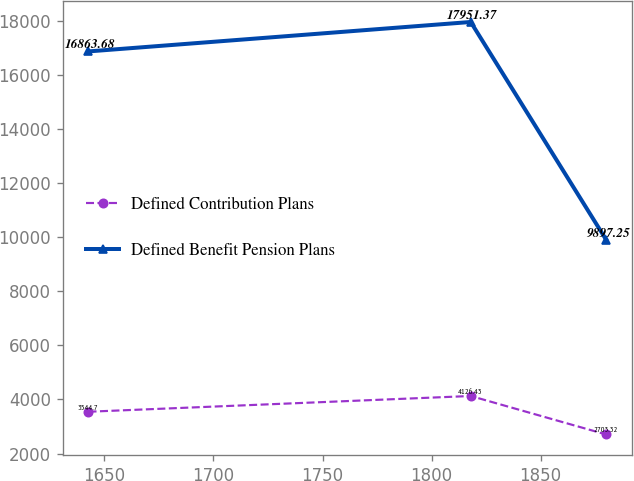Convert chart to OTSL. <chart><loc_0><loc_0><loc_500><loc_500><line_chart><ecel><fcel>Defined Contribution Plans<fcel>Defined Benefit Pension Plans<nl><fcel>1642.71<fcel>3544.7<fcel>16863.7<nl><fcel>1817.94<fcel>4126.43<fcel>17951.4<nl><fcel>1880.06<fcel>2703.32<fcel>9897.25<nl></chart> 